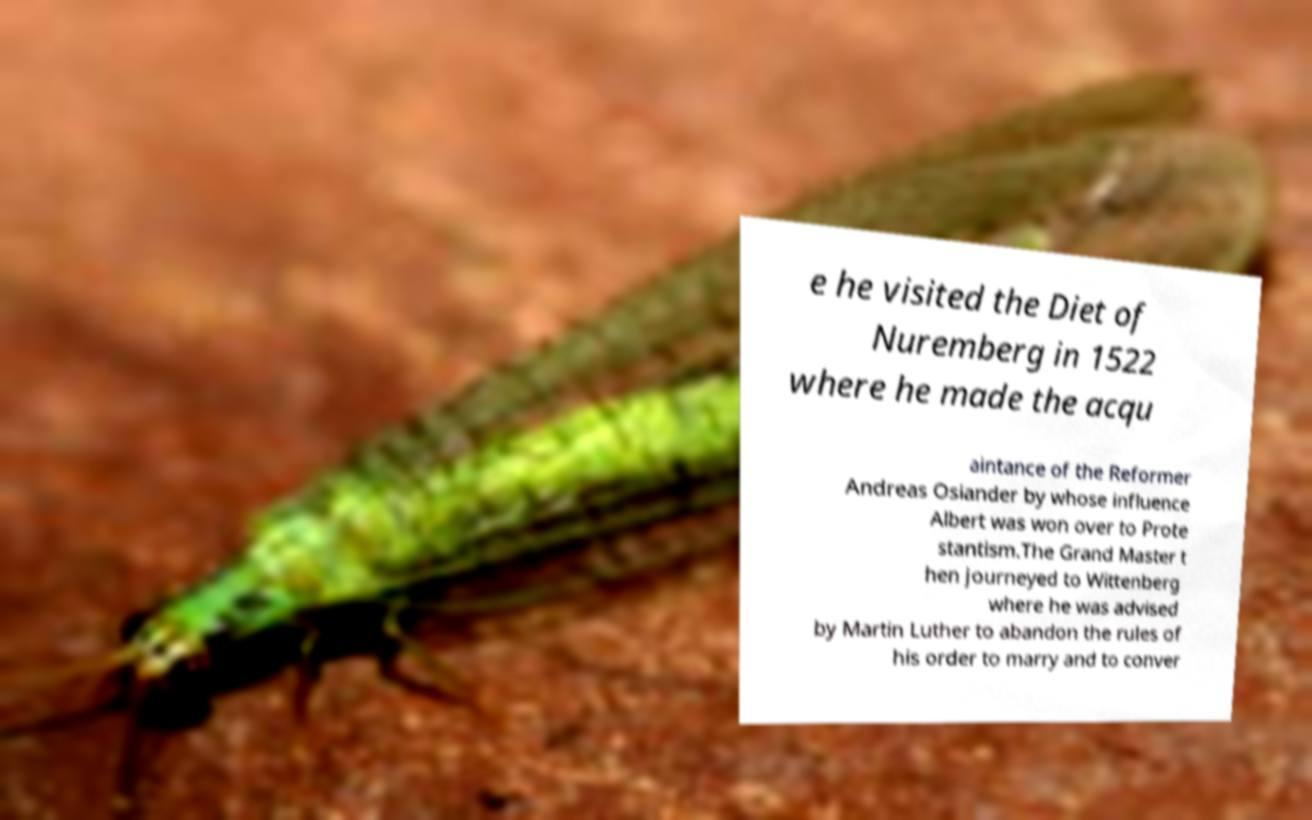There's text embedded in this image that I need extracted. Can you transcribe it verbatim? e he visited the Diet of Nuremberg in 1522 where he made the acqu aintance of the Reformer Andreas Osiander by whose influence Albert was won over to Prote stantism.The Grand Master t hen journeyed to Wittenberg where he was advised by Martin Luther to abandon the rules of his order to marry and to conver 